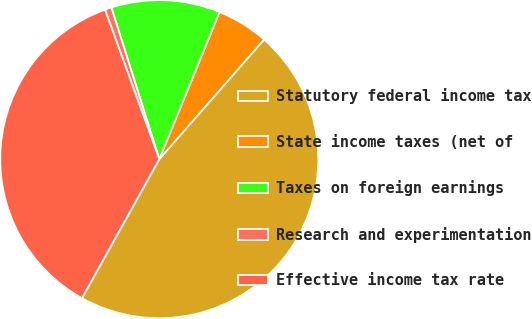<chart> <loc_0><loc_0><loc_500><loc_500><pie_chart><fcel>Statutory federal income tax<fcel>State income taxes (net of<fcel>Taxes on foreign earnings<fcel>Research and experimentation<fcel>Effective income tax rate<nl><fcel>46.64%<fcel>5.26%<fcel>11.06%<fcel>0.67%<fcel>36.38%<nl></chart> 